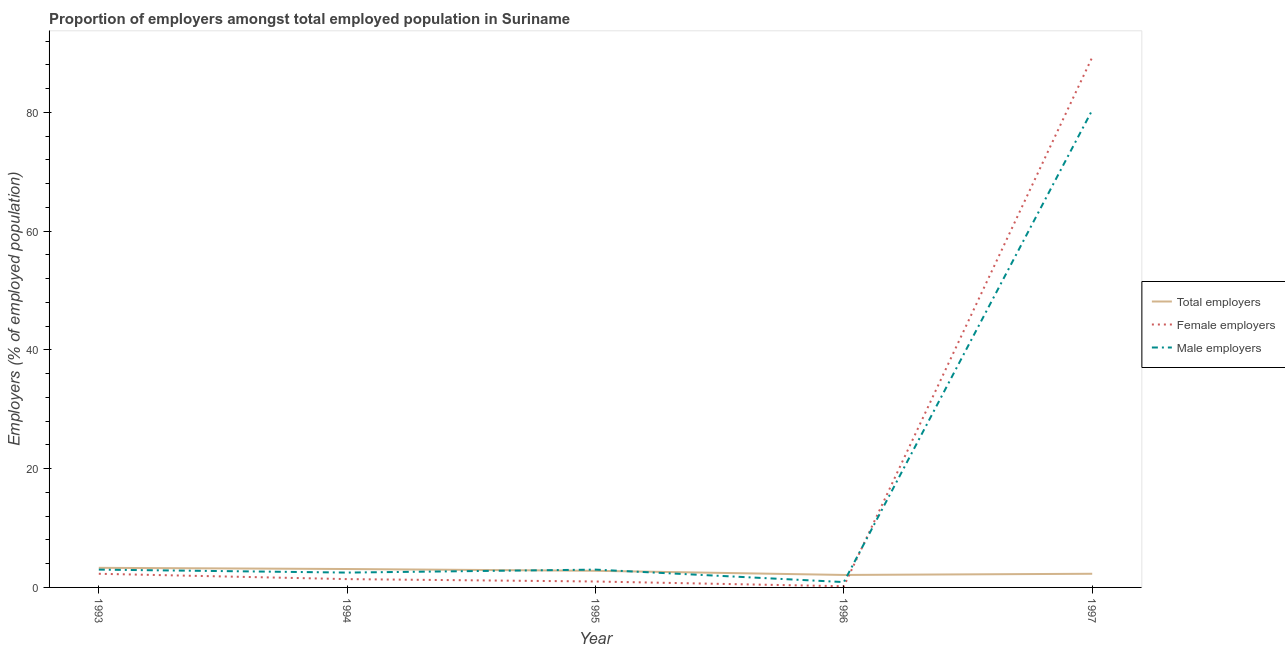How many different coloured lines are there?
Provide a succinct answer. 3. Does the line corresponding to percentage of total employers intersect with the line corresponding to percentage of male employers?
Your response must be concise. Yes. What is the percentage of total employers in 1995?
Ensure brevity in your answer.  2.8. Across all years, what is the maximum percentage of male employers?
Provide a short and direct response. 80.4. Across all years, what is the minimum percentage of total employers?
Your answer should be very brief. 2.1. In which year was the percentage of female employers maximum?
Provide a succinct answer. 1997. What is the total percentage of total employers in the graph?
Your response must be concise. 13.6. What is the difference between the percentage of female employers in 1995 and that in 1997?
Keep it short and to the point. -88.3. What is the difference between the percentage of female employers in 1994 and the percentage of male employers in 1993?
Your answer should be compact. -1.6. What is the average percentage of total employers per year?
Keep it short and to the point. 2.72. In the year 1993, what is the difference between the percentage of female employers and percentage of male employers?
Keep it short and to the point. -0.7. What is the ratio of the percentage of male employers in 1993 to that in 1996?
Your answer should be compact. 3.33. Is the difference between the percentage of male employers in 1994 and 1995 greater than the difference between the percentage of female employers in 1994 and 1995?
Offer a terse response. No. What is the difference between the highest and the second highest percentage of male employers?
Offer a terse response. 77.4. What is the difference between the highest and the lowest percentage of male employers?
Offer a terse response. 79.5. In how many years, is the percentage of total employers greater than the average percentage of total employers taken over all years?
Your answer should be compact. 3. Are the values on the major ticks of Y-axis written in scientific E-notation?
Make the answer very short. No. What is the title of the graph?
Your answer should be compact. Proportion of employers amongst total employed population in Suriname. Does "Ages 20-60" appear as one of the legend labels in the graph?
Make the answer very short. No. What is the label or title of the Y-axis?
Your answer should be compact. Employers (% of employed population). What is the Employers (% of employed population) in Total employers in 1993?
Your answer should be very brief. 3.3. What is the Employers (% of employed population) of Female employers in 1993?
Your answer should be compact. 2.3. What is the Employers (% of employed population) in Male employers in 1993?
Your response must be concise. 3. What is the Employers (% of employed population) in Total employers in 1994?
Give a very brief answer. 3.1. What is the Employers (% of employed population) in Female employers in 1994?
Your answer should be compact. 1.4. What is the Employers (% of employed population) of Total employers in 1995?
Offer a very short reply. 2.8. What is the Employers (% of employed population) in Female employers in 1995?
Your answer should be very brief. 1. What is the Employers (% of employed population) of Total employers in 1996?
Ensure brevity in your answer.  2.1. What is the Employers (% of employed population) in Female employers in 1996?
Provide a short and direct response. 0.2. What is the Employers (% of employed population) in Male employers in 1996?
Offer a terse response. 0.9. What is the Employers (% of employed population) in Total employers in 1997?
Give a very brief answer. 2.3. What is the Employers (% of employed population) in Female employers in 1997?
Ensure brevity in your answer.  89.3. What is the Employers (% of employed population) in Male employers in 1997?
Give a very brief answer. 80.4. Across all years, what is the maximum Employers (% of employed population) of Total employers?
Provide a succinct answer. 3.3. Across all years, what is the maximum Employers (% of employed population) in Female employers?
Give a very brief answer. 89.3. Across all years, what is the maximum Employers (% of employed population) of Male employers?
Provide a succinct answer. 80.4. Across all years, what is the minimum Employers (% of employed population) in Total employers?
Ensure brevity in your answer.  2.1. Across all years, what is the minimum Employers (% of employed population) of Female employers?
Your answer should be compact. 0.2. Across all years, what is the minimum Employers (% of employed population) in Male employers?
Offer a terse response. 0.9. What is the total Employers (% of employed population) of Total employers in the graph?
Provide a succinct answer. 13.6. What is the total Employers (% of employed population) of Female employers in the graph?
Offer a terse response. 94.2. What is the total Employers (% of employed population) of Male employers in the graph?
Keep it short and to the point. 89.8. What is the difference between the Employers (% of employed population) in Male employers in 1993 and that in 1995?
Ensure brevity in your answer.  0. What is the difference between the Employers (% of employed population) in Female employers in 1993 and that in 1997?
Offer a very short reply. -87. What is the difference between the Employers (% of employed population) in Male employers in 1993 and that in 1997?
Offer a very short reply. -77.4. What is the difference between the Employers (% of employed population) in Total employers in 1994 and that in 1995?
Provide a succinct answer. 0.3. What is the difference between the Employers (% of employed population) of Male employers in 1994 and that in 1995?
Make the answer very short. -0.5. What is the difference between the Employers (% of employed population) in Female employers in 1994 and that in 1997?
Make the answer very short. -87.9. What is the difference between the Employers (% of employed population) of Male employers in 1994 and that in 1997?
Your answer should be very brief. -77.9. What is the difference between the Employers (% of employed population) in Female employers in 1995 and that in 1996?
Offer a terse response. 0.8. What is the difference between the Employers (% of employed population) in Female employers in 1995 and that in 1997?
Offer a very short reply. -88.3. What is the difference between the Employers (% of employed population) of Male employers in 1995 and that in 1997?
Your answer should be compact. -77.4. What is the difference between the Employers (% of employed population) in Total employers in 1996 and that in 1997?
Give a very brief answer. -0.2. What is the difference between the Employers (% of employed population) of Female employers in 1996 and that in 1997?
Make the answer very short. -89.1. What is the difference between the Employers (% of employed population) in Male employers in 1996 and that in 1997?
Offer a terse response. -79.5. What is the difference between the Employers (% of employed population) in Total employers in 1993 and the Employers (% of employed population) in Female employers in 1994?
Give a very brief answer. 1.9. What is the difference between the Employers (% of employed population) of Total employers in 1993 and the Employers (% of employed population) of Female employers in 1995?
Offer a terse response. 2.3. What is the difference between the Employers (% of employed population) in Total employers in 1993 and the Employers (% of employed population) in Female employers in 1996?
Ensure brevity in your answer.  3.1. What is the difference between the Employers (% of employed population) of Total employers in 1993 and the Employers (% of employed population) of Male employers in 1996?
Make the answer very short. 2.4. What is the difference between the Employers (% of employed population) in Female employers in 1993 and the Employers (% of employed population) in Male employers in 1996?
Your answer should be very brief. 1.4. What is the difference between the Employers (% of employed population) of Total employers in 1993 and the Employers (% of employed population) of Female employers in 1997?
Make the answer very short. -86. What is the difference between the Employers (% of employed population) in Total employers in 1993 and the Employers (% of employed population) in Male employers in 1997?
Your answer should be very brief. -77.1. What is the difference between the Employers (% of employed population) of Female employers in 1993 and the Employers (% of employed population) of Male employers in 1997?
Keep it short and to the point. -78.1. What is the difference between the Employers (% of employed population) in Total employers in 1994 and the Employers (% of employed population) in Male employers in 1996?
Your response must be concise. 2.2. What is the difference between the Employers (% of employed population) of Total employers in 1994 and the Employers (% of employed population) of Female employers in 1997?
Give a very brief answer. -86.2. What is the difference between the Employers (% of employed population) of Total employers in 1994 and the Employers (% of employed population) of Male employers in 1997?
Provide a succinct answer. -77.3. What is the difference between the Employers (% of employed population) in Female employers in 1994 and the Employers (% of employed population) in Male employers in 1997?
Give a very brief answer. -79. What is the difference between the Employers (% of employed population) in Female employers in 1995 and the Employers (% of employed population) in Male employers in 1996?
Offer a terse response. 0.1. What is the difference between the Employers (% of employed population) in Total employers in 1995 and the Employers (% of employed population) in Female employers in 1997?
Provide a short and direct response. -86.5. What is the difference between the Employers (% of employed population) of Total employers in 1995 and the Employers (% of employed population) of Male employers in 1997?
Offer a very short reply. -77.6. What is the difference between the Employers (% of employed population) of Female employers in 1995 and the Employers (% of employed population) of Male employers in 1997?
Your answer should be compact. -79.4. What is the difference between the Employers (% of employed population) in Total employers in 1996 and the Employers (% of employed population) in Female employers in 1997?
Your answer should be compact. -87.2. What is the difference between the Employers (% of employed population) of Total employers in 1996 and the Employers (% of employed population) of Male employers in 1997?
Your answer should be compact. -78.3. What is the difference between the Employers (% of employed population) of Female employers in 1996 and the Employers (% of employed population) of Male employers in 1997?
Offer a terse response. -80.2. What is the average Employers (% of employed population) in Total employers per year?
Your answer should be very brief. 2.72. What is the average Employers (% of employed population) of Female employers per year?
Your response must be concise. 18.84. What is the average Employers (% of employed population) in Male employers per year?
Offer a terse response. 17.96. In the year 1993, what is the difference between the Employers (% of employed population) in Total employers and Employers (% of employed population) in Male employers?
Offer a terse response. 0.3. In the year 1994, what is the difference between the Employers (% of employed population) in Total employers and Employers (% of employed population) in Female employers?
Ensure brevity in your answer.  1.7. In the year 1995, what is the difference between the Employers (% of employed population) in Total employers and Employers (% of employed population) in Male employers?
Your answer should be compact. -0.2. In the year 1996, what is the difference between the Employers (% of employed population) of Total employers and Employers (% of employed population) of Female employers?
Provide a short and direct response. 1.9. In the year 1996, what is the difference between the Employers (% of employed population) in Total employers and Employers (% of employed population) in Male employers?
Provide a succinct answer. 1.2. In the year 1996, what is the difference between the Employers (% of employed population) of Female employers and Employers (% of employed population) of Male employers?
Ensure brevity in your answer.  -0.7. In the year 1997, what is the difference between the Employers (% of employed population) in Total employers and Employers (% of employed population) in Female employers?
Your answer should be compact. -87. In the year 1997, what is the difference between the Employers (% of employed population) in Total employers and Employers (% of employed population) in Male employers?
Your answer should be very brief. -78.1. In the year 1997, what is the difference between the Employers (% of employed population) of Female employers and Employers (% of employed population) of Male employers?
Offer a terse response. 8.9. What is the ratio of the Employers (% of employed population) of Total employers in 1993 to that in 1994?
Your response must be concise. 1.06. What is the ratio of the Employers (% of employed population) of Female employers in 1993 to that in 1994?
Keep it short and to the point. 1.64. What is the ratio of the Employers (% of employed population) of Total employers in 1993 to that in 1995?
Provide a short and direct response. 1.18. What is the ratio of the Employers (% of employed population) in Female employers in 1993 to that in 1995?
Provide a short and direct response. 2.3. What is the ratio of the Employers (% of employed population) of Total employers in 1993 to that in 1996?
Your answer should be compact. 1.57. What is the ratio of the Employers (% of employed population) of Total employers in 1993 to that in 1997?
Offer a terse response. 1.43. What is the ratio of the Employers (% of employed population) of Female employers in 1993 to that in 1997?
Your answer should be compact. 0.03. What is the ratio of the Employers (% of employed population) of Male employers in 1993 to that in 1997?
Your answer should be very brief. 0.04. What is the ratio of the Employers (% of employed population) of Total employers in 1994 to that in 1995?
Keep it short and to the point. 1.11. What is the ratio of the Employers (% of employed population) of Female employers in 1994 to that in 1995?
Ensure brevity in your answer.  1.4. What is the ratio of the Employers (% of employed population) of Male employers in 1994 to that in 1995?
Give a very brief answer. 0.83. What is the ratio of the Employers (% of employed population) of Total employers in 1994 to that in 1996?
Give a very brief answer. 1.48. What is the ratio of the Employers (% of employed population) of Male employers in 1994 to that in 1996?
Your answer should be very brief. 2.78. What is the ratio of the Employers (% of employed population) in Total employers in 1994 to that in 1997?
Offer a very short reply. 1.35. What is the ratio of the Employers (% of employed population) in Female employers in 1994 to that in 1997?
Provide a succinct answer. 0.02. What is the ratio of the Employers (% of employed population) of Male employers in 1994 to that in 1997?
Provide a succinct answer. 0.03. What is the ratio of the Employers (% of employed population) in Total employers in 1995 to that in 1996?
Keep it short and to the point. 1.33. What is the ratio of the Employers (% of employed population) in Female employers in 1995 to that in 1996?
Ensure brevity in your answer.  5. What is the ratio of the Employers (% of employed population) of Total employers in 1995 to that in 1997?
Keep it short and to the point. 1.22. What is the ratio of the Employers (% of employed population) of Female employers in 1995 to that in 1997?
Your answer should be very brief. 0.01. What is the ratio of the Employers (% of employed population) in Male employers in 1995 to that in 1997?
Keep it short and to the point. 0.04. What is the ratio of the Employers (% of employed population) of Female employers in 1996 to that in 1997?
Provide a short and direct response. 0. What is the ratio of the Employers (% of employed population) of Male employers in 1996 to that in 1997?
Provide a succinct answer. 0.01. What is the difference between the highest and the second highest Employers (% of employed population) of Female employers?
Ensure brevity in your answer.  87. What is the difference between the highest and the second highest Employers (% of employed population) in Male employers?
Your response must be concise. 77.4. What is the difference between the highest and the lowest Employers (% of employed population) of Total employers?
Your answer should be very brief. 1.2. What is the difference between the highest and the lowest Employers (% of employed population) in Female employers?
Give a very brief answer. 89.1. What is the difference between the highest and the lowest Employers (% of employed population) of Male employers?
Provide a succinct answer. 79.5. 